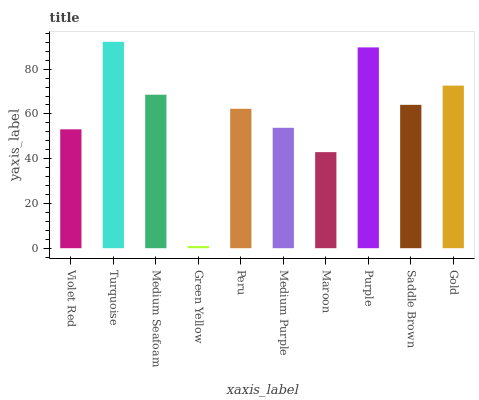Is Green Yellow the minimum?
Answer yes or no. Yes. Is Turquoise the maximum?
Answer yes or no. Yes. Is Medium Seafoam the minimum?
Answer yes or no. No. Is Medium Seafoam the maximum?
Answer yes or no. No. Is Turquoise greater than Medium Seafoam?
Answer yes or no. Yes. Is Medium Seafoam less than Turquoise?
Answer yes or no. Yes. Is Medium Seafoam greater than Turquoise?
Answer yes or no. No. Is Turquoise less than Medium Seafoam?
Answer yes or no. No. Is Saddle Brown the high median?
Answer yes or no. Yes. Is Peru the low median?
Answer yes or no. Yes. Is Gold the high median?
Answer yes or no. No. Is Violet Red the low median?
Answer yes or no. No. 